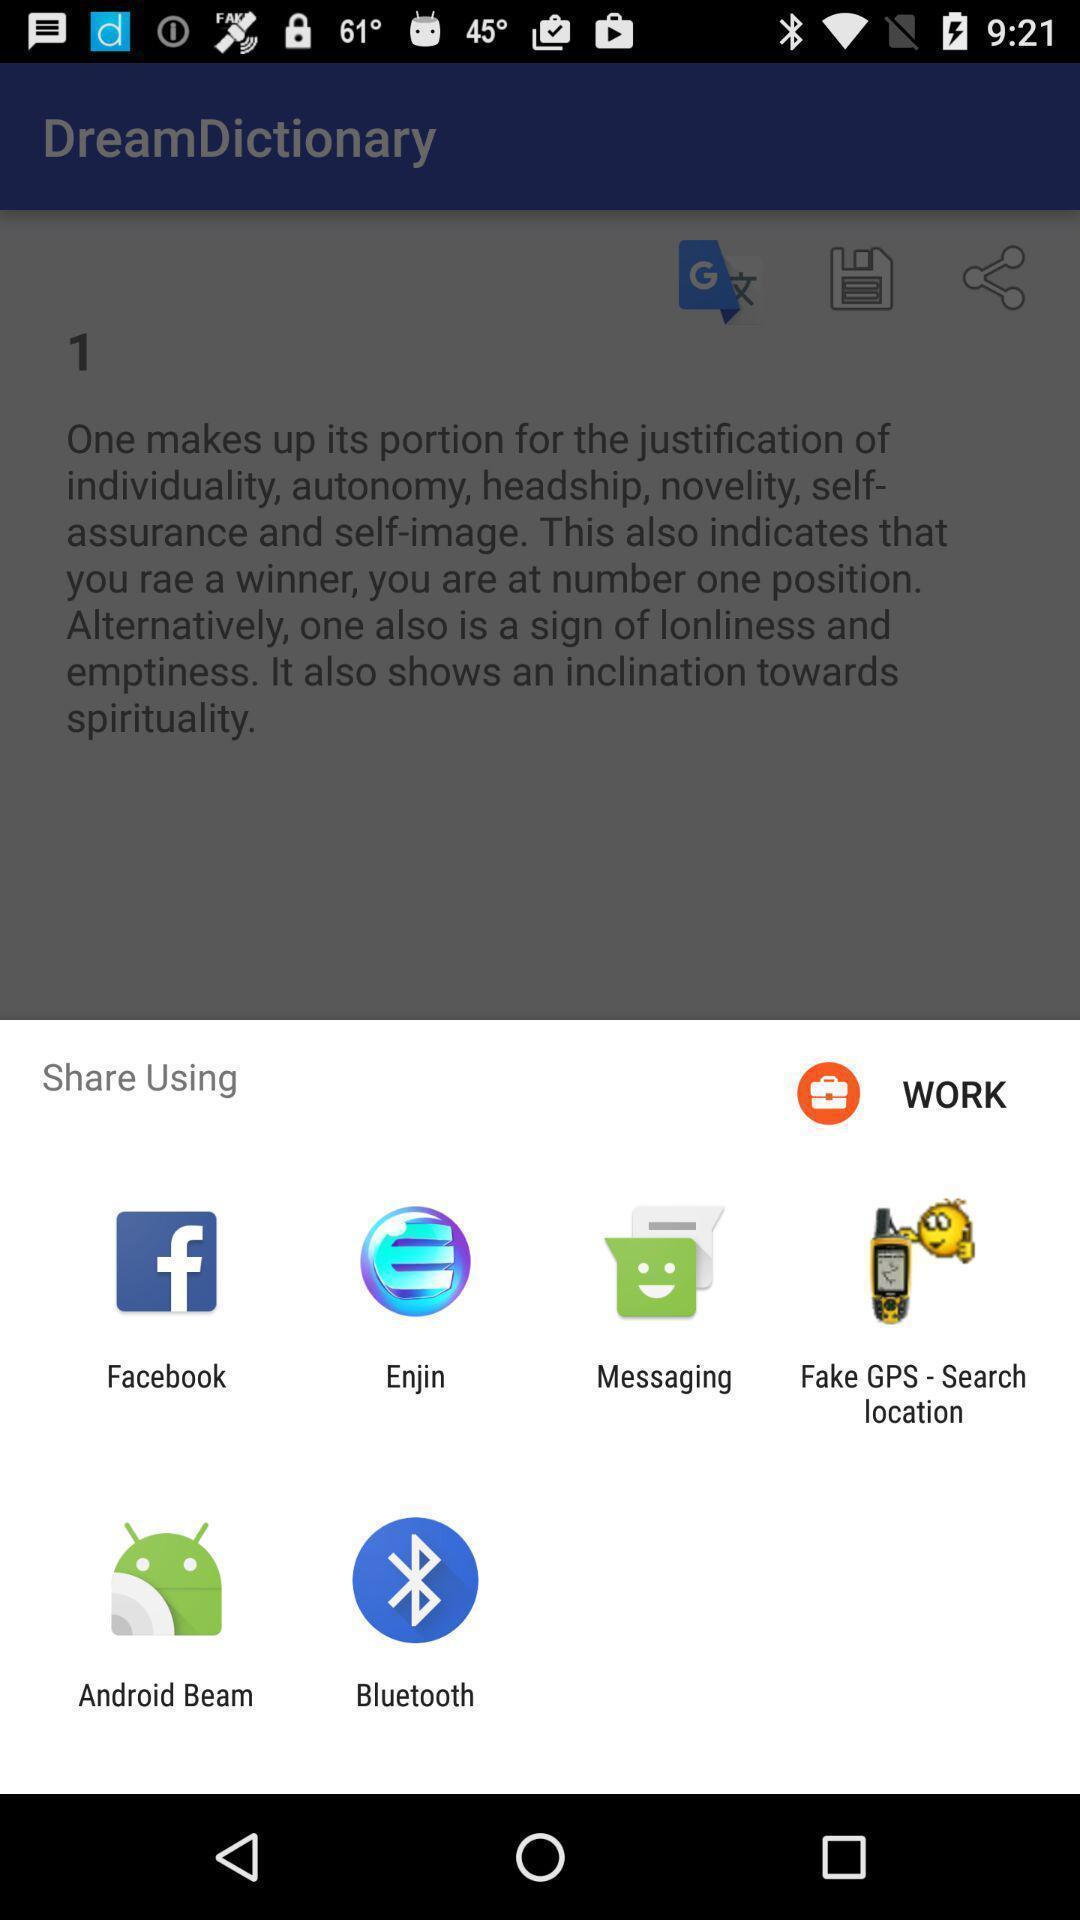Summarize the information in this screenshot. Pop-up shows to share using multiple applications. 